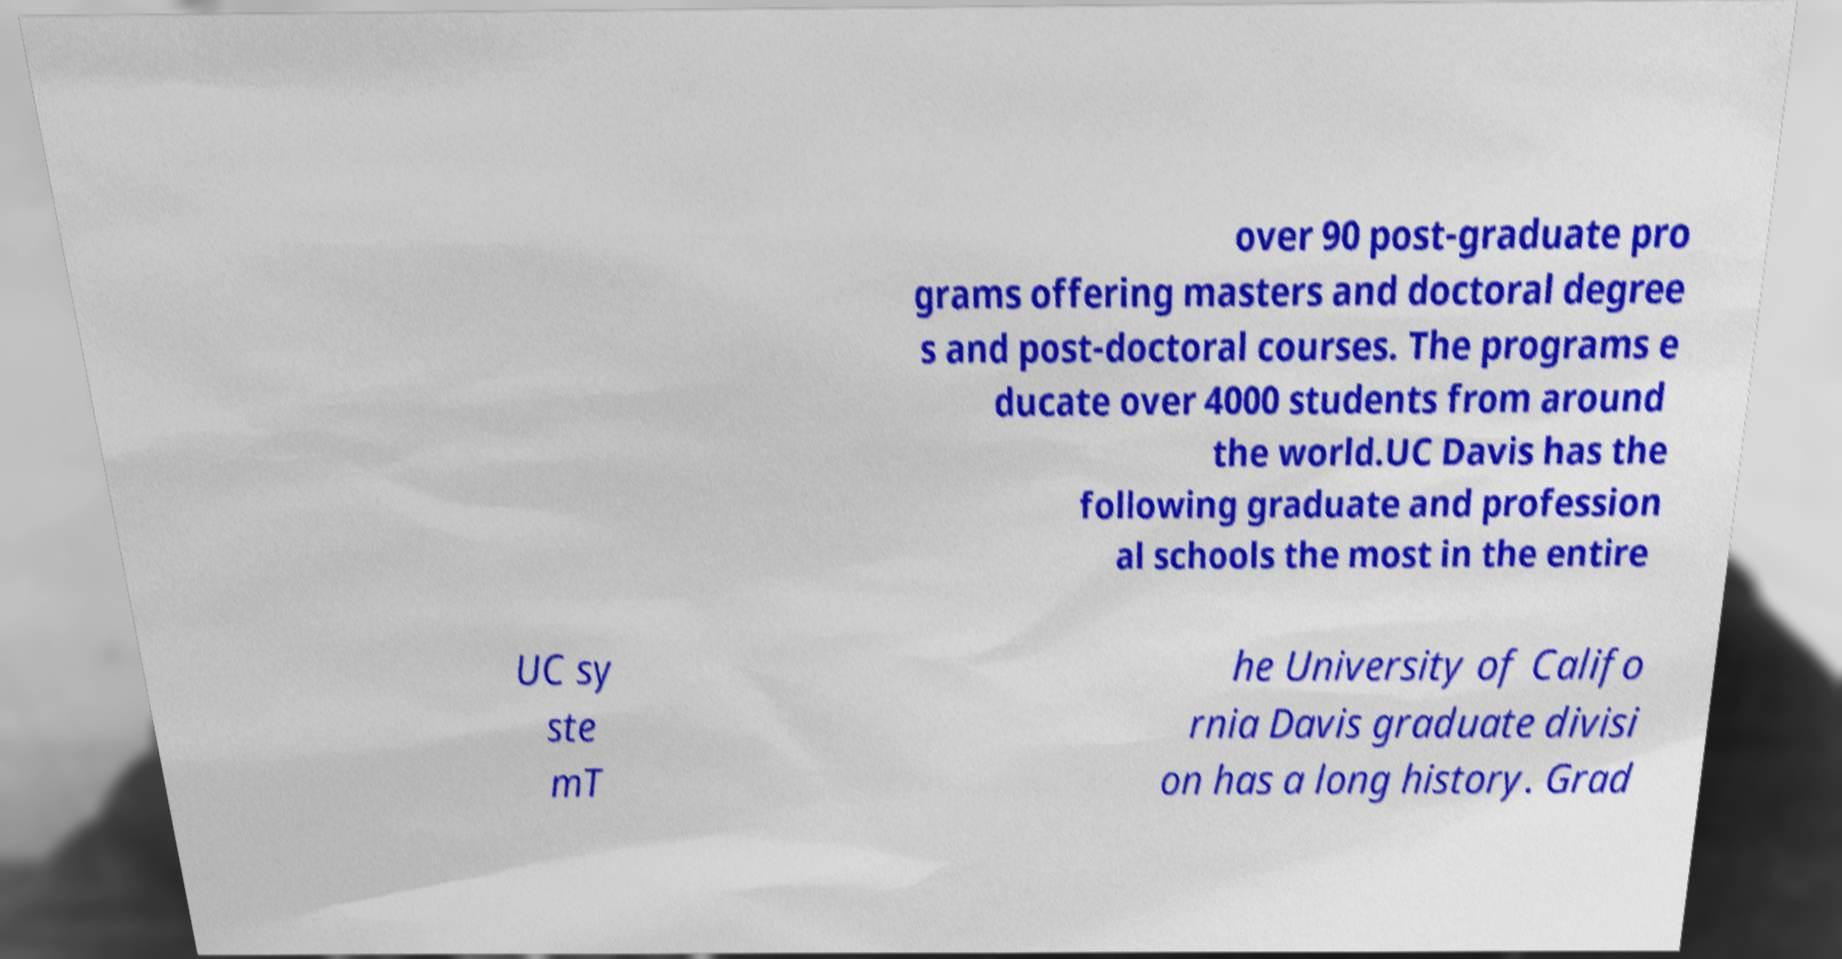There's text embedded in this image that I need extracted. Can you transcribe it verbatim? over 90 post-graduate pro grams offering masters and doctoral degree s and post-doctoral courses. The programs e ducate over 4000 students from around the world.UC Davis has the following graduate and profession al schools the most in the entire UC sy ste mT he University of Califo rnia Davis graduate divisi on has a long history. Grad 